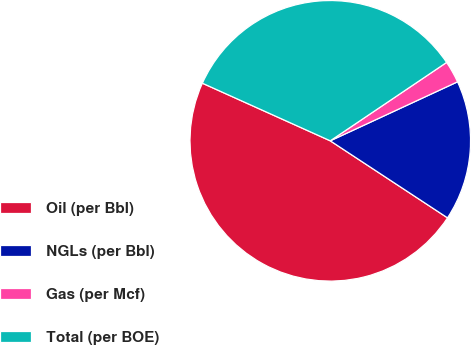Convert chart to OTSL. <chart><loc_0><loc_0><loc_500><loc_500><pie_chart><fcel>Oil (per Bbl)<fcel>NGLs (per Bbl)<fcel>Gas (per Mcf)<fcel>Total (per BOE)<nl><fcel>47.49%<fcel>16.16%<fcel>2.53%<fcel>33.83%<nl></chart> 